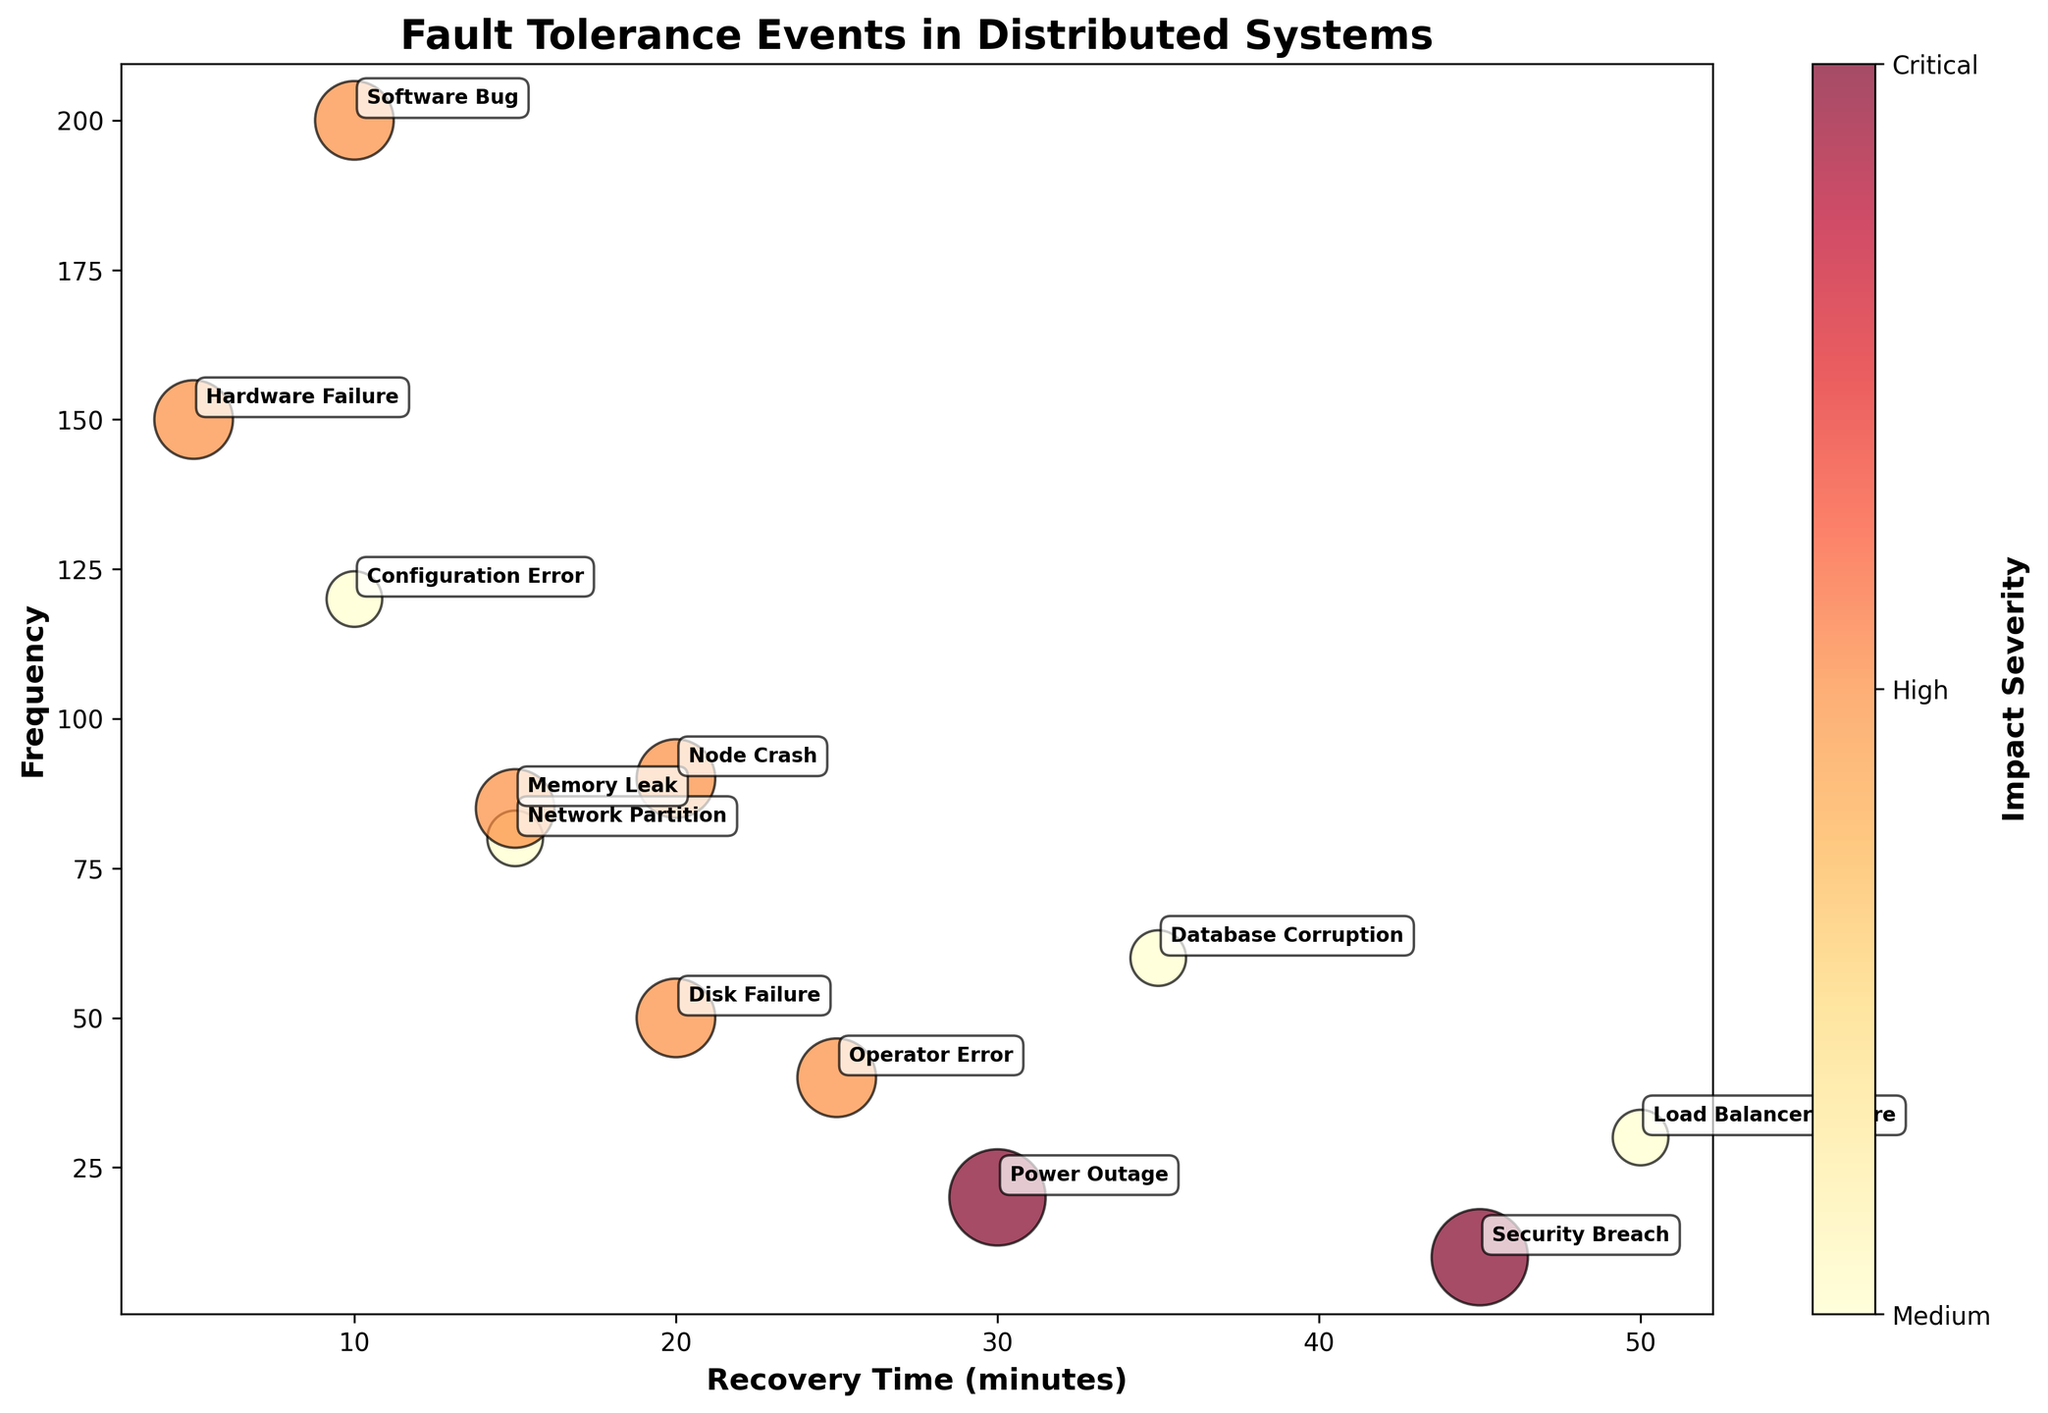What is the title of the plot? The title is usually displayed at the top of the plot in a visually distinctive font. By reading the text, we can directly answer this question.
Answer: Fault Tolerance Events in Distributed Systems How many failure types are represented in the plot? Each unique bubble in the plot represents a distinct failure type. By counting these unique data points, we can answer the question.
Answer: 12 Which failure type has the highest frequency? To find this, look for the bubble that is positioned highest on the Y-axis. The label next to this highest bubble will indicate the failure type.
Answer: Software Bug How many bubbles represent a "Critical" impact severity? Bubbles' colors and the color bar on the right side of the plot can help identify the impact severity. Count the bubbles that match the color mapped to "Critical".
Answer: 2 What's the recovery time for the failure type with the highest impact severity? Look for the bubbles with the biggest size (since impact severity is mapped to bubble size) and then find the label next to it.
Answer: Power Outage and Security Breach, both 30 and 45 minutes respectively Which entity has a network partition issue and what is its corresponding frequency and recovery time? By checking the labels for "Network Partition" and referring to the X and Y coordinates of its bubble, we can find this information.
Answer: Google Cloud Platform, 80, 15 minutes Which failure type has a lower impact severity, "Disk Failure" or "Node Crash"? Compare the colors and sizes of the bubbles for "Disk Failure" and "Node Crash". The mapping on the color bar shows which severity is lower.
Answer: Both have High impact severity, so they are equal Compare the recovery times of "Configuration Error" and "Memory Leak". Which recovers faster? Locate the bubbles for these failure types and compare their X-coordinates. A lower X-coordinate means a faster recovery time.
Answer: Configuration Error recovers faster (10 minutes vs. 15 minutes) How many failure types have a recovery time of 20 minutes or more? By observing the X-axis, count the number of bubbles located at or beyond the 20-minute mark.
Answer: 6 What is the difference in frequency between "Hardware Failure" and "Database Corruption"? Identify the bubbles for these failure types and note their Y-coordinates (frequencies), then calculate the absolute difference.
Answer: 90 